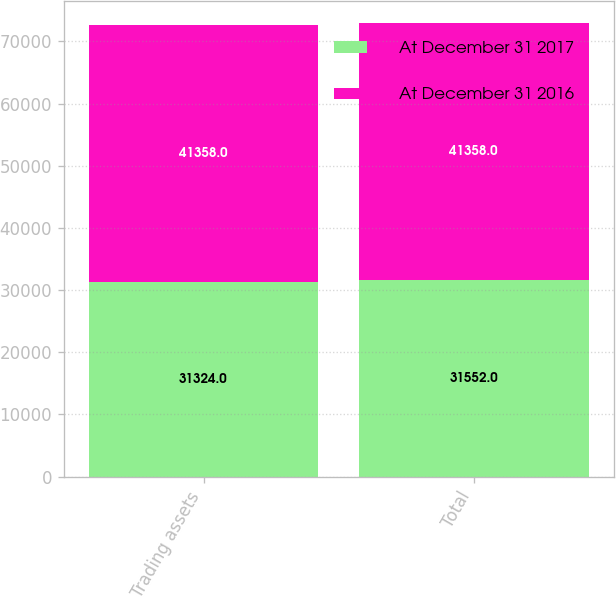Convert chart to OTSL. <chart><loc_0><loc_0><loc_500><loc_500><stacked_bar_chart><ecel><fcel>Trading assets<fcel>Total<nl><fcel>At December 31 2017<fcel>31324<fcel>31552<nl><fcel>At December 31 2016<fcel>41358<fcel>41358<nl></chart> 